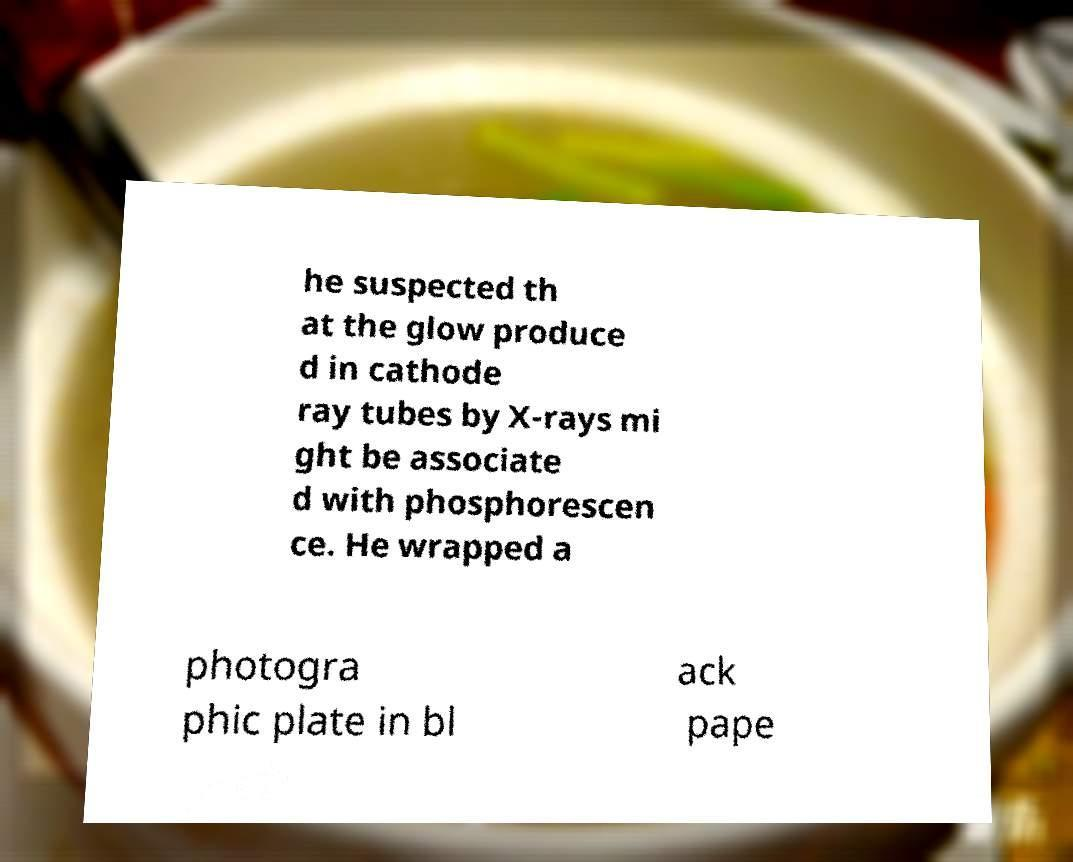Please read and relay the text visible in this image. What does it say? he suspected th at the glow produce d in cathode ray tubes by X-rays mi ght be associate d with phosphorescen ce. He wrapped a photogra phic plate in bl ack pape 